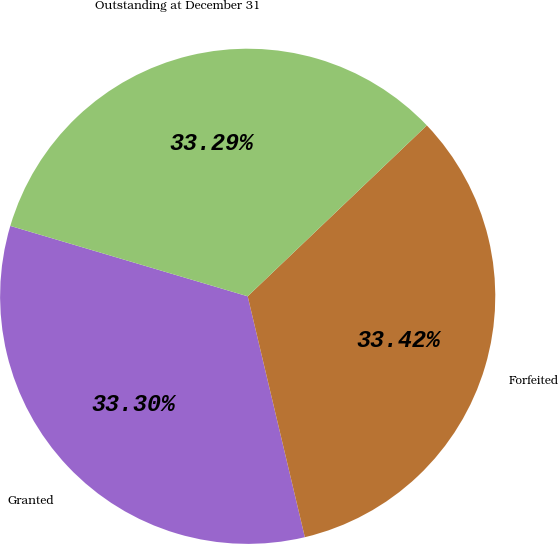Convert chart to OTSL. <chart><loc_0><loc_0><loc_500><loc_500><pie_chart><fcel>Granted<fcel>Forfeited<fcel>Outstanding at December 31<nl><fcel>33.3%<fcel>33.42%<fcel>33.29%<nl></chart> 